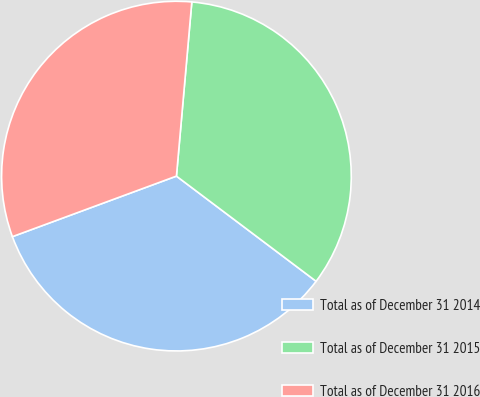Convert chart. <chart><loc_0><loc_0><loc_500><loc_500><pie_chart><fcel>Total as of December 31 2014<fcel>Total as of December 31 2015<fcel>Total as of December 31 2016<nl><fcel>34.1%<fcel>33.87%<fcel>32.03%<nl></chart> 